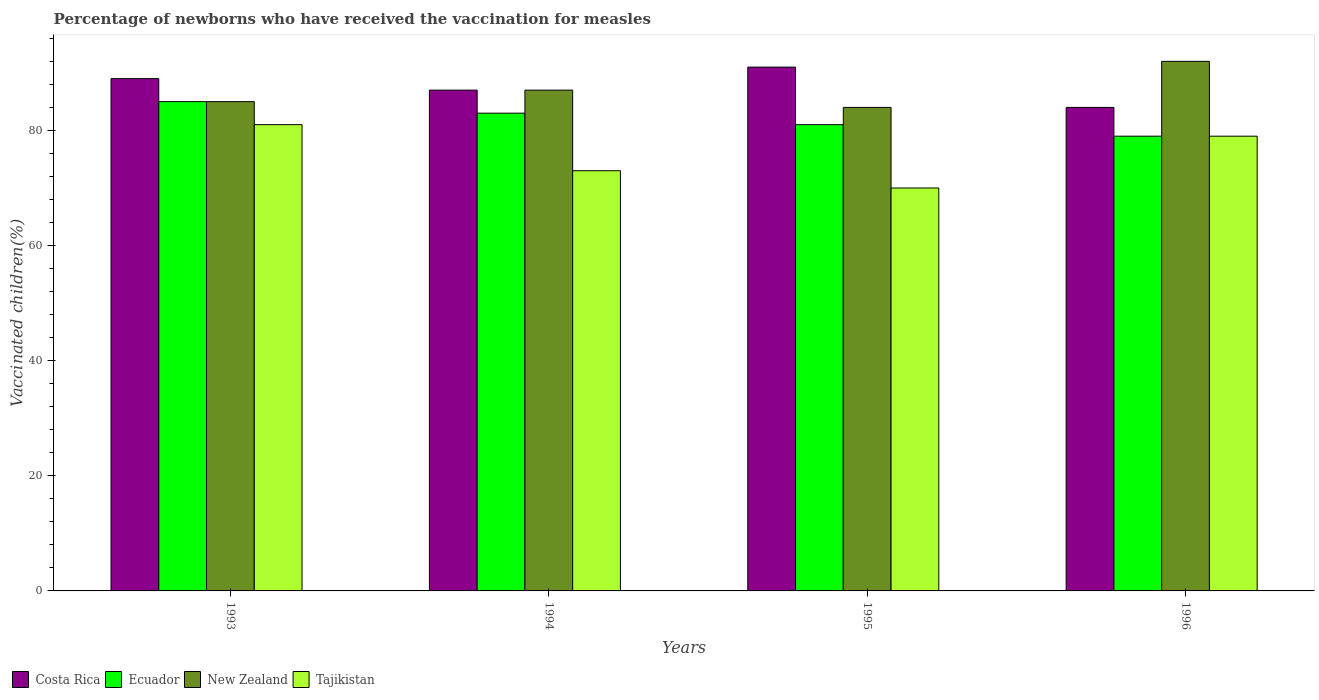Are the number of bars on each tick of the X-axis equal?
Offer a terse response. Yes. How many bars are there on the 1st tick from the left?
Your answer should be very brief. 4. How many bars are there on the 4th tick from the right?
Provide a short and direct response. 4. What is the label of the 3rd group of bars from the left?
Your response must be concise. 1995. What is the percentage of vaccinated children in Ecuador in 1994?
Offer a very short reply. 83. Across all years, what is the maximum percentage of vaccinated children in Costa Rica?
Offer a terse response. 91. In which year was the percentage of vaccinated children in Costa Rica minimum?
Offer a very short reply. 1996. What is the total percentage of vaccinated children in Costa Rica in the graph?
Make the answer very short. 351. What is the difference between the percentage of vaccinated children in Ecuador in 1993 and that in 1996?
Your answer should be very brief. 6. What is the difference between the percentage of vaccinated children in Ecuador in 1993 and the percentage of vaccinated children in Tajikistan in 1994?
Provide a short and direct response. 12. In the year 1995, what is the difference between the percentage of vaccinated children in Tajikistan and percentage of vaccinated children in Ecuador?
Offer a very short reply. -11. What is the ratio of the percentage of vaccinated children in Costa Rica in 1993 to that in 1995?
Ensure brevity in your answer.  0.98. What is the difference between the highest and the second highest percentage of vaccinated children in Ecuador?
Your response must be concise. 2. Is the sum of the percentage of vaccinated children in New Zealand in 1995 and 1996 greater than the maximum percentage of vaccinated children in Costa Rica across all years?
Keep it short and to the point. Yes. Is it the case that in every year, the sum of the percentage of vaccinated children in Costa Rica and percentage of vaccinated children in New Zealand is greater than the sum of percentage of vaccinated children in Ecuador and percentage of vaccinated children in Tajikistan?
Provide a short and direct response. Yes. What does the 3rd bar from the left in 1994 represents?
Make the answer very short. New Zealand. What does the 2nd bar from the right in 1994 represents?
Offer a terse response. New Zealand. How many bars are there?
Your answer should be very brief. 16. Are all the bars in the graph horizontal?
Ensure brevity in your answer.  No. Does the graph contain any zero values?
Ensure brevity in your answer.  No. Does the graph contain grids?
Provide a succinct answer. No. Where does the legend appear in the graph?
Ensure brevity in your answer.  Bottom left. How are the legend labels stacked?
Your answer should be compact. Horizontal. What is the title of the graph?
Your response must be concise. Percentage of newborns who have received the vaccination for measles. Does "Timor-Leste" appear as one of the legend labels in the graph?
Offer a very short reply. No. What is the label or title of the Y-axis?
Ensure brevity in your answer.  Vaccinated children(%). What is the Vaccinated children(%) of Costa Rica in 1993?
Keep it short and to the point. 89. What is the Vaccinated children(%) of Tajikistan in 1993?
Offer a terse response. 81. What is the Vaccinated children(%) in Costa Rica in 1994?
Your answer should be compact. 87. What is the Vaccinated children(%) of Tajikistan in 1994?
Offer a terse response. 73. What is the Vaccinated children(%) in Costa Rica in 1995?
Your answer should be very brief. 91. What is the Vaccinated children(%) of Tajikistan in 1995?
Provide a short and direct response. 70. What is the Vaccinated children(%) in Ecuador in 1996?
Provide a short and direct response. 79. What is the Vaccinated children(%) of New Zealand in 1996?
Make the answer very short. 92. What is the Vaccinated children(%) in Tajikistan in 1996?
Your response must be concise. 79. Across all years, what is the maximum Vaccinated children(%) in Costa Rica?
Offer a terse response. 91. Across all years, what is the maximum Vaccinated children(%) of New Zealand?
Your answer should be very brief. 92. Across all years, what is the minimum Vaccinated children(%) in Costa Rica?
Ensure brevity in your answer.  84. Across all years, what is the minimum Vaccinated children(%) of Ecuador?
Offer a terse response. 79. Across all years, what is the minimum Vaccinated children(%) in Tajikistan?
Offer a very short reply. 70. What is the total Vaccinated children(%) in Costa Rica in the graph?
Your response must be concise. 351. What is the total Vaccinated children(%) in Ecuador in the graph?
Give a very brief answer. 328. What is the total Vaccinated children(%) in New Zealand in the graph?
Offer a terse response. 348. What is the total Vaccinated children(%) in Tajikistan in the graph?
Ensure brevity in your answer.  303. What is the difference between the Vaccinated children(%) of New Zealand in 1993 and that in 1994?
Make the answer very short. -2. What is the difference between the Vaccinated children(%) of Ecuador in 1993 and that in 1995?
Give a very brief answer. 4. What is the difference between the Vaccinated children(%) of New Zealand in 1993 and that in 1995?
Provide a short and direct response. 1. What is the difference between the Vaccinated children(%) of Ecuador in 1993 and that in 1996?
Make the answer very short. 6. What is the difference between the Vaccinated children(%) of Tajikistan in 1993 and that in 1996?
Keep it short and to the point. 2. What is the difference between the Vaccinated children(%) in New Zealand in 1994 and that in 1995?
Give a very brief answer. 3. What is the difference between the Vaccinated children(%) of Ecuador in 1994 and that in 1996?
Provide a short and direct response. 4. What is the difference between the Vaccinated children(%) of New Zealand in 1994 and that in 1996?
Give a very brief answer. -5. What is the difference between the Vaccinated children(%) of Tajikistan in 1994 and that in 1996?
Your answer should be compact. -6. What is the difference between the Vaccinated children(%) of Costa Rica in 1995 and that in 1996?
Offer a very short reply. 7. What is the difference between the Vaccinated children(%) of Ecuador in 1995 and that in 1996?
Your response must be concise. 2. What is the difference between the Vaccinated children(%) in New Zealand in 1995 and that in 1996?
Make the answer very short. -8. What is the difference between the Vaccinated children(%) in Tajikistan in 1995 and that in 1996?
Your answer should be compact. -9. What is the difference between the Vaccinated children(%) of Costa Rica in 1993 and the Vaccinated children(%) of Tajikistan in 1994?
Your answer should be very brief. 16. What is the difference between the Vaccinated children(%) of Ecuador in 1993 and the Vaccinated children(%) of New Zealand in 1994?
Keep it short and to the point. -2. What is the difference between the Vaccinated children(%) in Costa Rica in 1993 and the Vaccinated children(%) in Ecuador in 1995?
Make the answer very short. 8. What is the difference between the Vaccinated children(%) in Costa Rica in 1993 and the Vaccinated children(%) in New Zealand in 1995?
Offer a very short reply. 5. What is the difference between the Vaccinated children(%) of Costa Rica in 1993 and the Vaccinated children(%) of Tajikistan in 1995?
Keep it short and to the point. 19. What is the difference between the Vaccinated children(%) of Ecuador in 1993 and the Vaccinated children(%) of New Zealand in 1995?
Offer a terse response. 1. What is the difference between the Vaccinated children(%) of Ecuador in 1993 and the Vaccinated children(%) of Tajikistan in 1995?
Provide a succinct answer. 15. What is the difference between the Vaccinated children(%) in Costa Rica in 1993 and the Vaccinated children(%) in New Zealand in 1996?
Provide a short and direct response. -3. What is the difference between the Vaccinated children(%) of Ecuador in 1993 and the Vaccinated children(%) of Tajikistan in 1996?
Ensure brevity in your answer.  6. What is the difference between the Vaccinated children(%) in Costa Rica in 1994 and the Vaccinated children(%) in Ecuador in 1995?
Offer a very short reply. 6. What is the difference between the Vaccinated children(%) in Costa Rica in 1994 and the Vaccinated children(%) in New Zealand in 1995?
Provide a succinct answer. 3. What is the difference between the Vaccinated children(%) of Ecuador in 1994 and the Vaccinated children(%) of New Zealand in 1995?
Provide a short and direct response. -1. What is the difference between the Vaccinated children(%) of New Zealand in 1994 and the Vaccinated children(%) of Tajikistan in 1995?
Offer a terse response. 17. What is the difference between the Vaccinated children(%) in Costa Rica in 1994 and the Vaccinated children(%) in New Zealand in 1996?
Ensure brevity in your answer.  -5. What is the difference between the Vaccinated children(%) in Ecuador in 1994 and the Vaccinated children(%) in New Zealand in 1996?
Your answer should be compact. -9. What is the difference between the Vaccinated children(%) in New Zealand in 1994 and the Vaccinated children(%) in Tajikistan in 1996?
Provide a short and direct response. 8. What is the difference between the Vaccinated children(%) of Costa Rica in 1995 and the Vaccinated children(%) of Tajikistan in 1996?
Ensure brevity in your answer.  12. What is the difference between the Vaccinated children(%) in Ecuador in 1995 and the Vaccinated children(%) in New Zealand in 1996?
Your answer should be compact. -11. What is the difference between the Vaccinated children(%) of Ecuador in 1995 and the Vaccinated children(%) of Tajikistan in 1996?
Ensure brevity in your answer.  2. What is the difference between the Vaccinated children(%) of New Zealand in 1995 and the Vaccinated children(%) of Tajikistan in 1996?
Keep it short and to the point. 5. What is the average Vaccinated children(%) in Costa Rica per year?
Offer a terse response. 87.75. What is the average Vaccinated children(%) of Ecuador per year?
Ensure brevity in your answer.  82. What is the average Vaccinated children(%) of New Zealand per year?
Offer a very short reply. 87. What is the average Vaccinated children(%) in Tajikistan per year?
Provide a short and direct response. 75.75. In the year 1993, what is the difference between the Vaccinated children(%) in Costa Rica and Vaccinated children(%) in New Zealand?
Your response must be concise. 4. In the year 1993, what is the difference between the Vaccinated children(%) of Ecuador and Vaccinated children(%) of New Zealand?
Your answer should be compact. 0. In the year 1993, what is the difference between the Vaccinated children(%) in Ecuador and Vaccinated children(%) in Tajikistan?
Give a very brief answer. 4. In the year 1994, what is the difference between the Vaccinated children(%) of Costa Rica and Vaccinated children(%) of New Zealand?
Offer a terse response. 0. In the year 1994, what is the difference between the Vaccinated children(%) in New Zealand and Vaccinated children(%) in Tajikistan?
Your answer should be compact. 14. In the year 1995, what is the difference between the Vaccinated children(%) of Costa Rica and Vaccinated children(%) of New Zealand?
Keep it short and to the point. 7. In the year 1995, what is the difference between the Vaccinated children(%) in Costa Rica and Vaccinated children(%) in Tajikistan?
Your answer should be very brief. 21. In the year 1995, what is the difference between the Vaccinated children(%) of Ecuador and Vaccinated children(%) of Tajikistan?
Your answer should be compact. 11. In the year 1995, what is the difference between the Vaccinated children(%) of New Zealand and Vaccinated children(%) of Tajikistan?
Give a very brief answer. 14. In the year 1996, what is the difference between the Vaccinated children(%) of Costa Rica and Vaccinated children(%) of Ecuador?
Make the answer very short. 5. In the year 1996, what is the difference between the Vaccinated children(%) in Costa Rica and Vaccinated children(%) in Tajikistan?
Your answer should be compact. 5. In the year 1996, what is the difference between the Vaccinated children(%) in Ecuador and Vaccinated children(%) in New Zealand?
Ensure brevity in your answer.  -13. What is the ratio of the Vaccinated children(%) in Costa Rica in 1993 to that in 1994?
Your answer should be very brief. 1.02. What is the ratio of the Vaccinated children(%) of Ecuador in 1993 to that in 1994?
Make the answer very short. 1.02. What is the ratio of the Vaccinated children(%) of Tajikistan in 1993 to that in 1994?
Your answer should be very brief. 1.11. What is the ratio of the Vaccinated children(%) of Ecuador in 1993 to that in 1995?
Give a very brief answer. 1.05. What is the ratio of the Vaccinated children(%) in New Zealand in 1993 to that in 1995?
Your response must be concise. 1.01. What is the ratio of the Vaccinated children(%) of Tajikistan in 1993 to that in 1995?
Your answer should be very brief. 1.16. What is the ratio of the Vaccinated children(%) of Costa Rica in 1993 to that in 1996?
Provide a succinct answer. 1.06. What is the ratio of the Vaccinated children(%) in Ecuador in 1993 to that in 1996?
Make the answer very short. 1.08. What is the ratio of the Vaccinated children(%) of New Zealand in 1993 to that in 1996?
Provide a short and direct response. 0.92. What is the ratio of the Vaccinated children(%) of Tajikistan in 1993 to that in 1996?
Make the answer very short. 1.03. What is the ratio of the Vaccinated children(%) of Costa Rica in 1994 to that in 1995?
Your answer should be very brief. 0.96. What is the ratio of the Vaccinated children(%) of Ecuador in 1994 to that in 1995?
Offer a very short reply. 1.02. What is the ratio of the Vaccinated children(%) in New Zealand in 1994 to that in 1995?
Provide a short and direct response. 1.04. What is the ratio of the Vaccinated children(%) of Tajikistan in 1994 to that in 1995?
Provide a succinct answer. 1.04. What is the ratio of the Vaccinated children(%) in Costa Rica in 1994 to that in 1996?
Provide a short and direct response. 1.04. What is the ratio of the Vaccinated children(%) in Ecuador in 1994 to that in 1996?
Ensure brevity in your answer.  1.05. What is the ratio of the Vaccinated children(%) in New Zealand in 1994 to that in 1996?
Your answer should be very brief. 0.95. What is the ratio of the Vaccinated children(%) of Tajikistan in 1994 to that in 1996?
Your response must be concise. 0.92. What is the ratio of the Vaccinated children(%) in Ecuador in 1995 to that in 1996?
Provide a short and direct response. 1.03. What is the ratio of the Vaccinated children(%) in Tajikistan in 1995 to that in 1996?
Your response must be concise. 0.89. What is the difference between the highest and the second highest Vaccinated children(%) of Costa Rica?
Provide a short and direct response. 2. What is the difference between the highest and the lowest Vaccinated children(%) in Costa Rica?
Keep it short and to the point. 7. What is the difference between the highest and the lowest Vaccinated children(%) of Ecuador?
Ensure brevity in your answer.  6. 